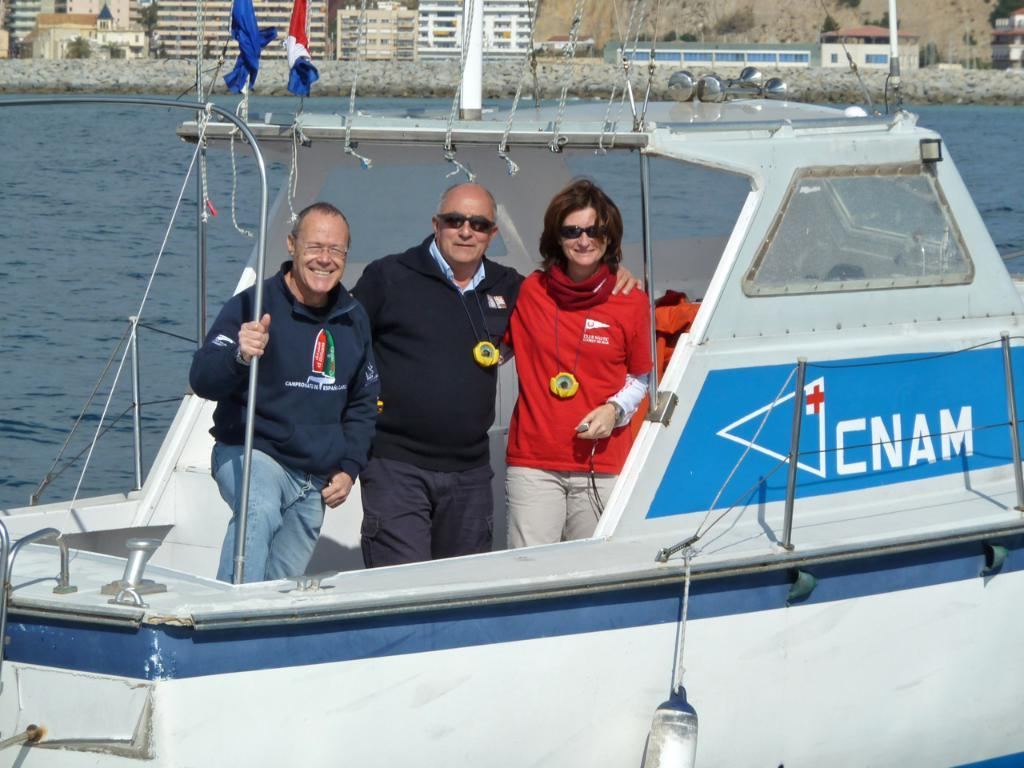<image>
Write a terse but informative summary of the picture. 2 men and a woman on a boat with CNAM printed on the side. 